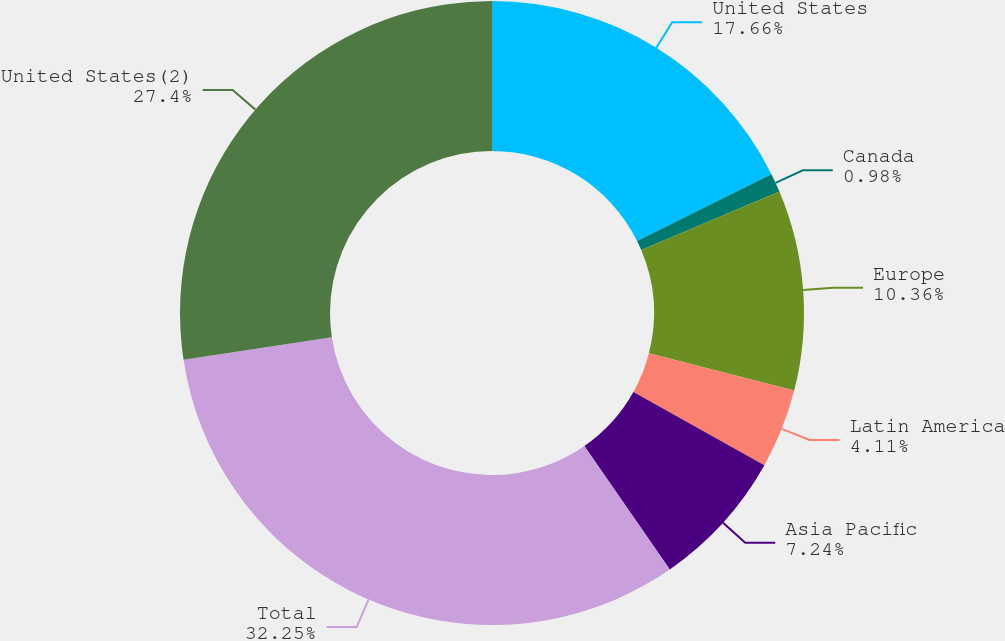Convert chart. <chart><loc_0><loc_0><loc_500><loc_500><pie_chart><fcel>United States<fcel>Canada<fcel>Europe<fcel>Latin America<fcel>Asia Pacific<fcel>Total<fcel>United States(2)<nl><fcel>17.66%<fcel>0.98%<fcel>10.36%<fcel>4.11%<fcel>7.24%<fcel>32.25%<fcel>27.4%<nl></chart> 